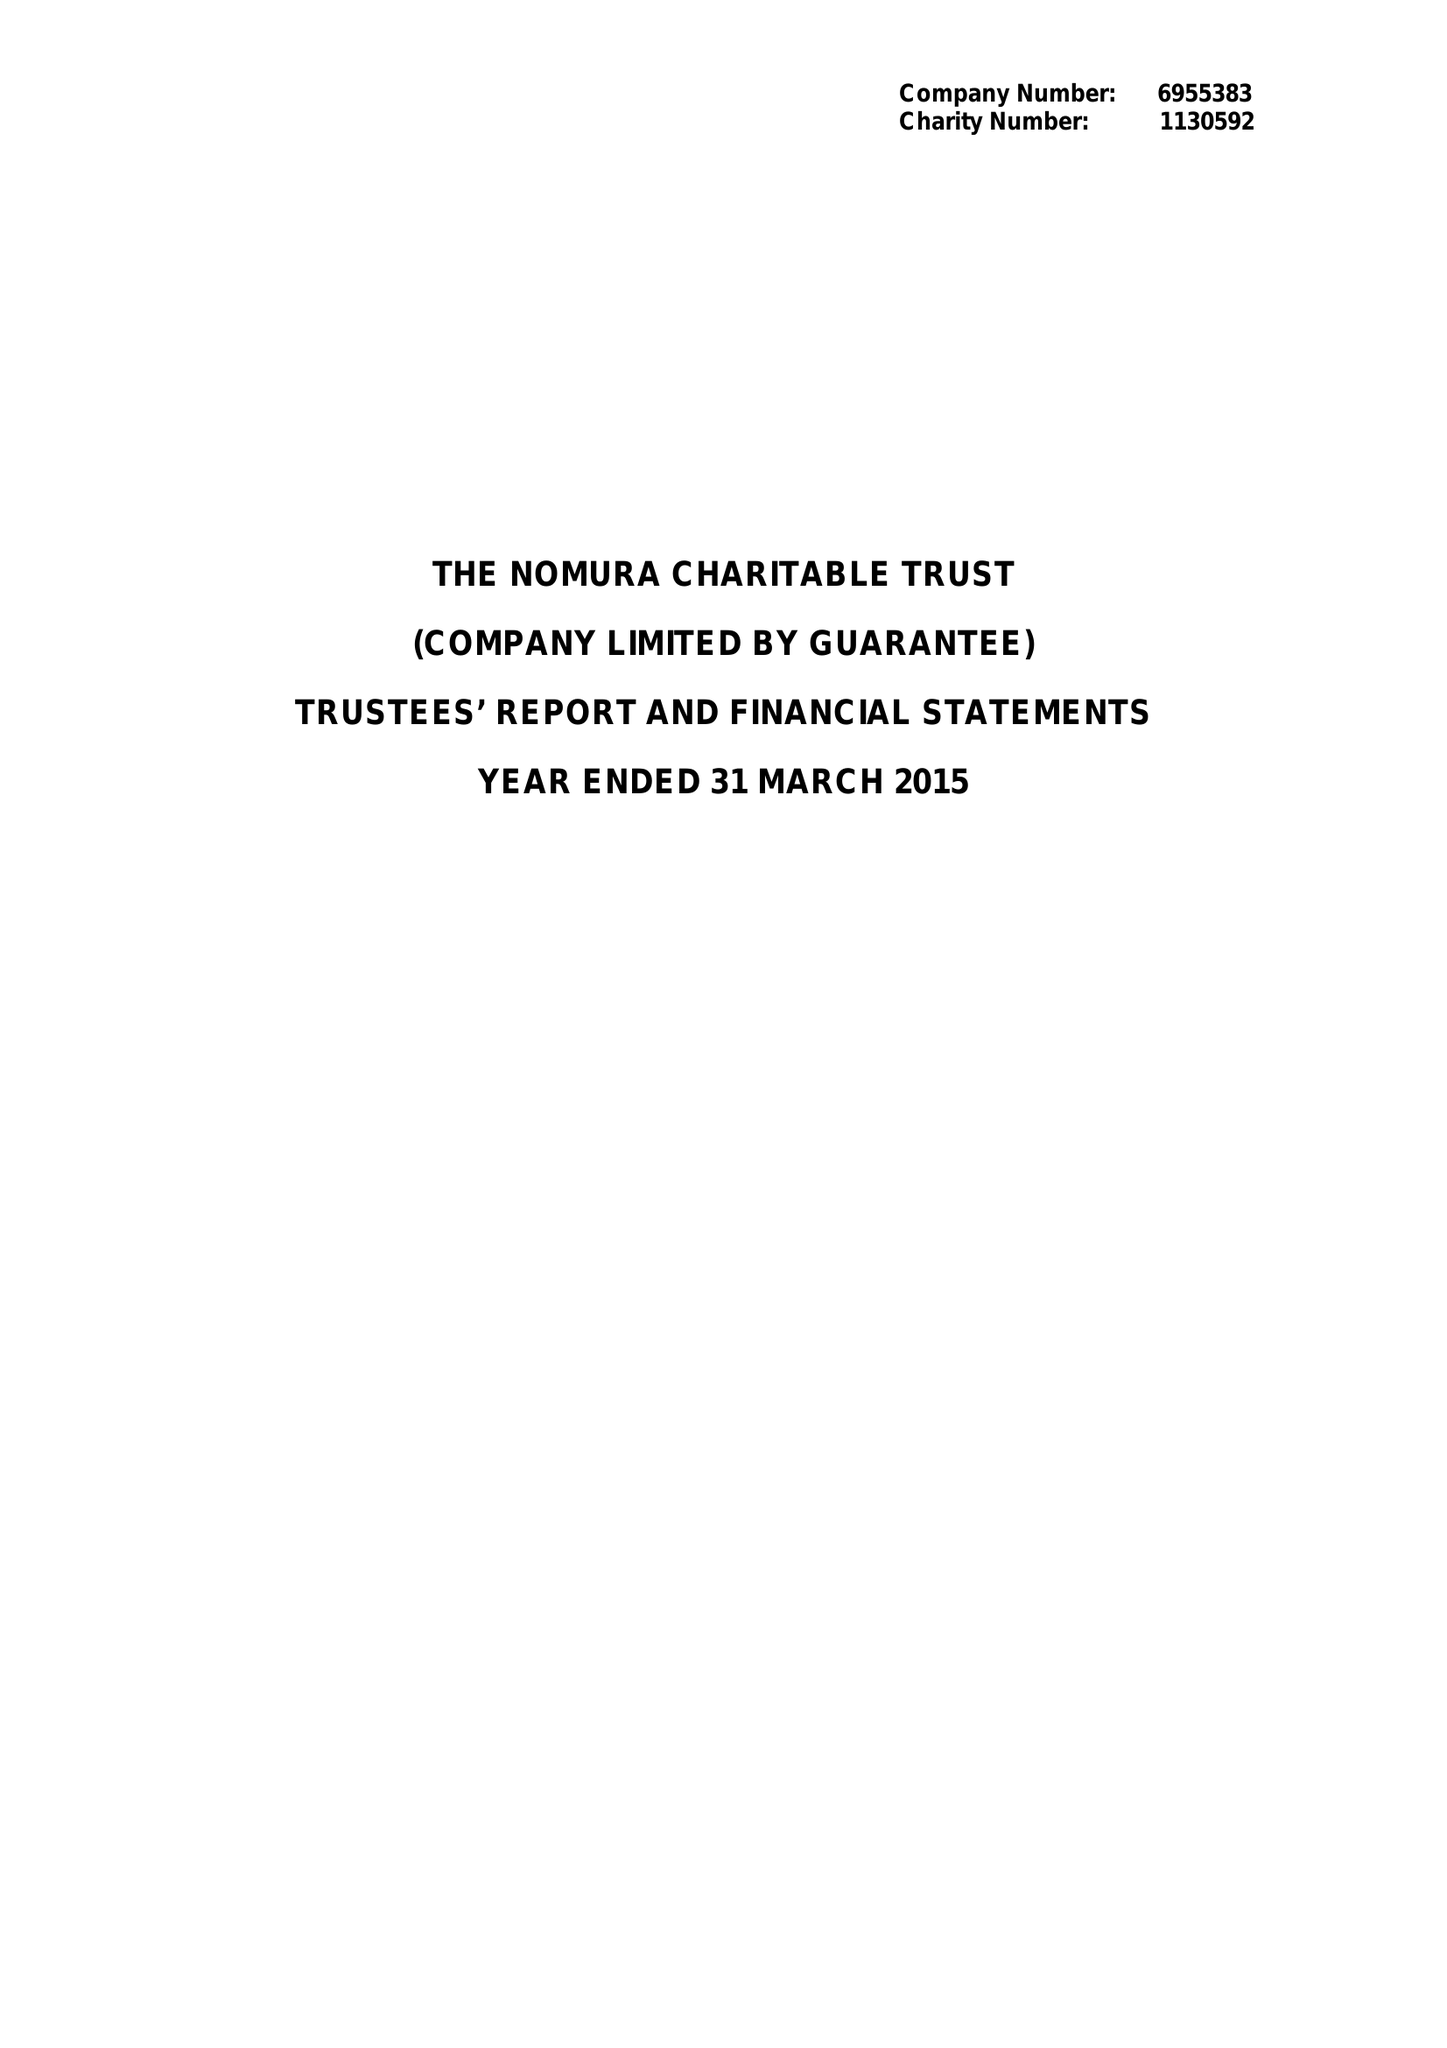What is the value for the address__street_line?
Answer the question using a single word or phrase. 1 ANGEL LANE 